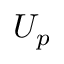<formula> <loc_0><loc_0><loc_500><loc_500>U _ { p }</formula> 